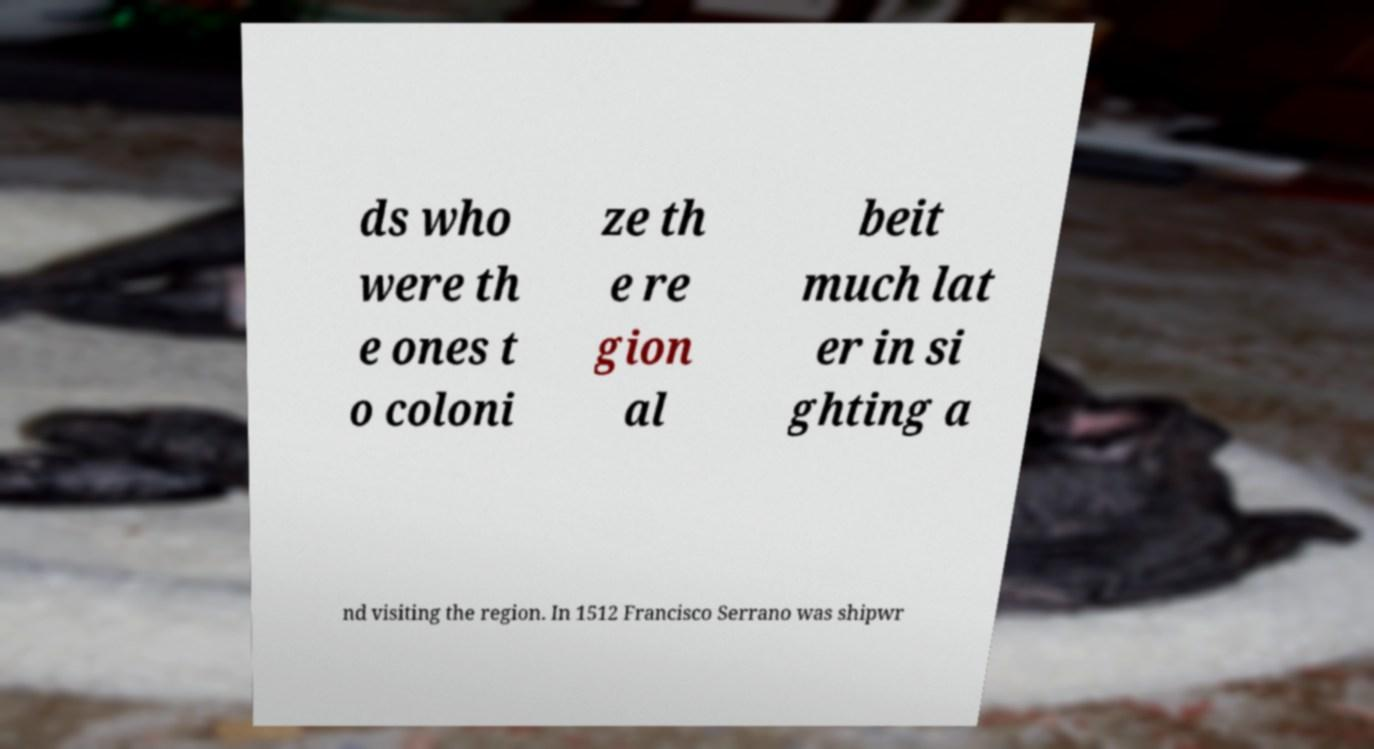What messages or text are displayed in this image? I need them in a readable, typed format. ds who were th e ones t o coloni ze th e re gion al beit much lat er in si ghting a nd visiting the region. In 1512 Francisco Serrano was shipwr 